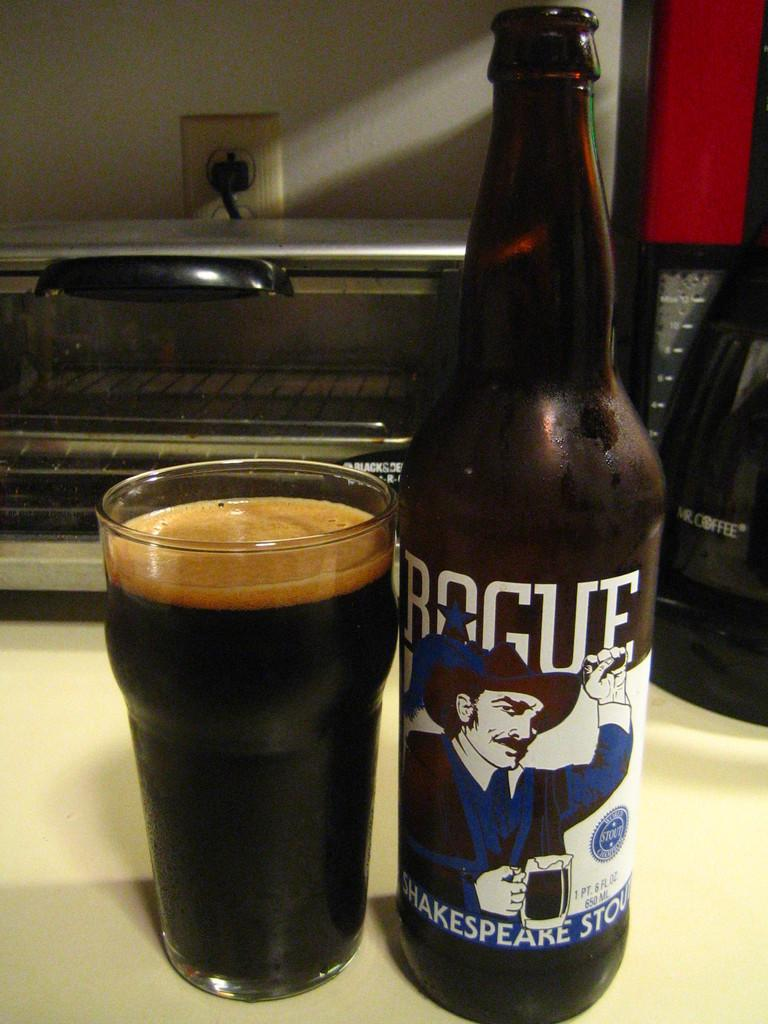<image>
Create a compact narrative representing the image presented. A bottle of Rogue Shakespeare Stout sits next to a full glass. 